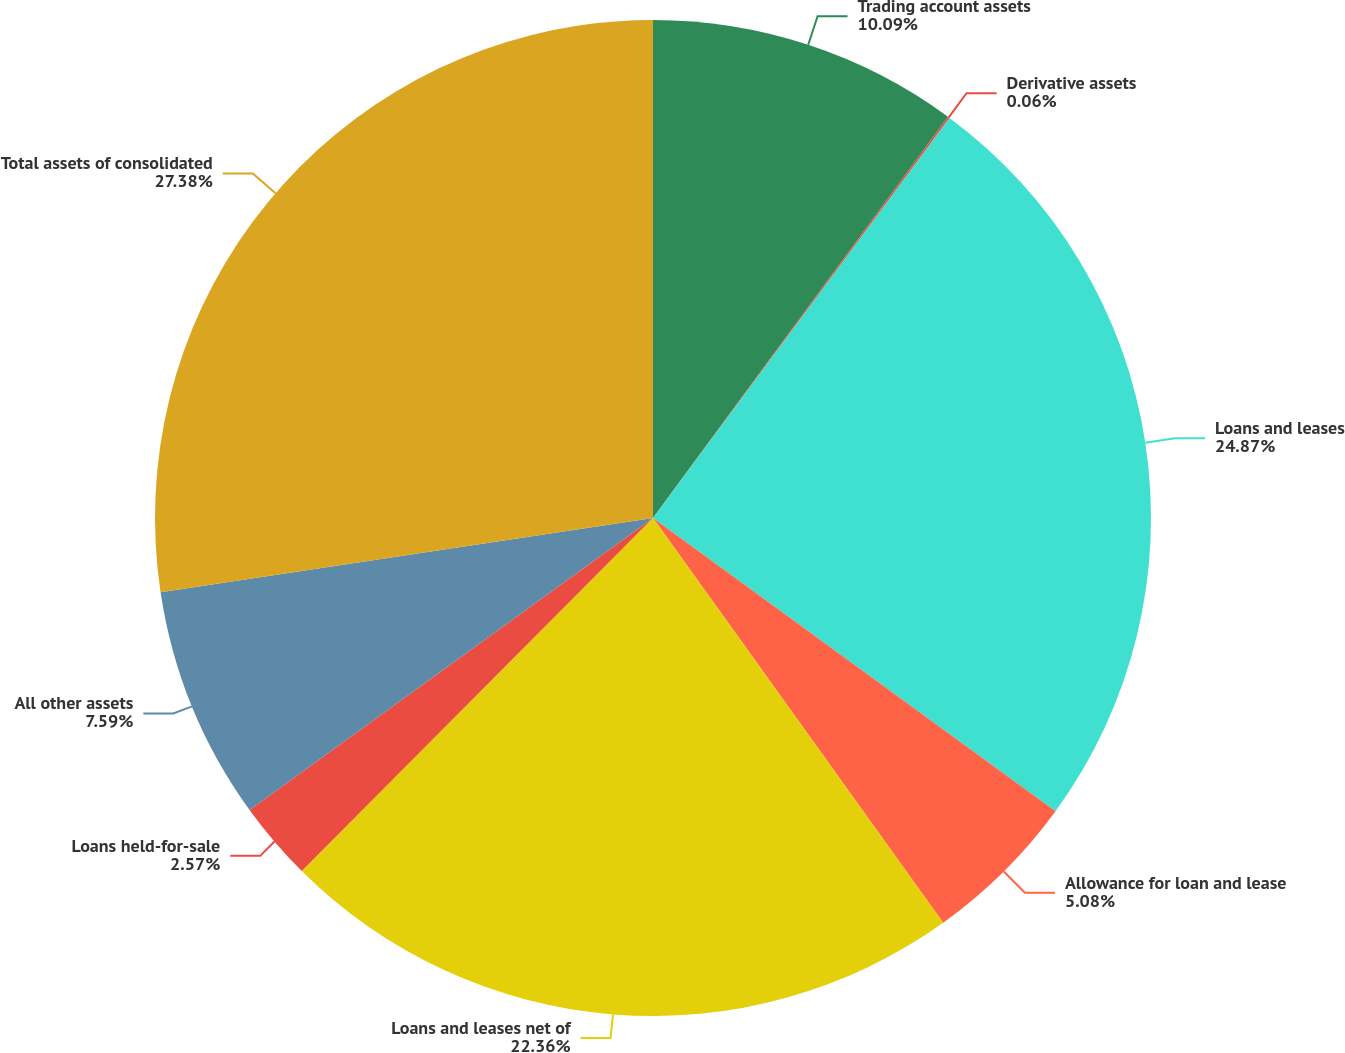<chart> <loc_0><loc_0><loc_500><loc_500><pie_chart><fcel>Trading account assets<fcel>Derivative assets<fcel>Loans and leases<fcel>Allowance for loan and lease<fcel>Loans and leases net of<fcel>Loans held-for-sale<fcel>All other assets<fcel>Total assets of consolidated<nl><fcel>10.09%<fcel>0.06%<fcel>24.87%<fcel>5.08%<fcel>22.36%<fcel>2.57%<fcel>7.59%<fcel>27.38%<nl></chart> 